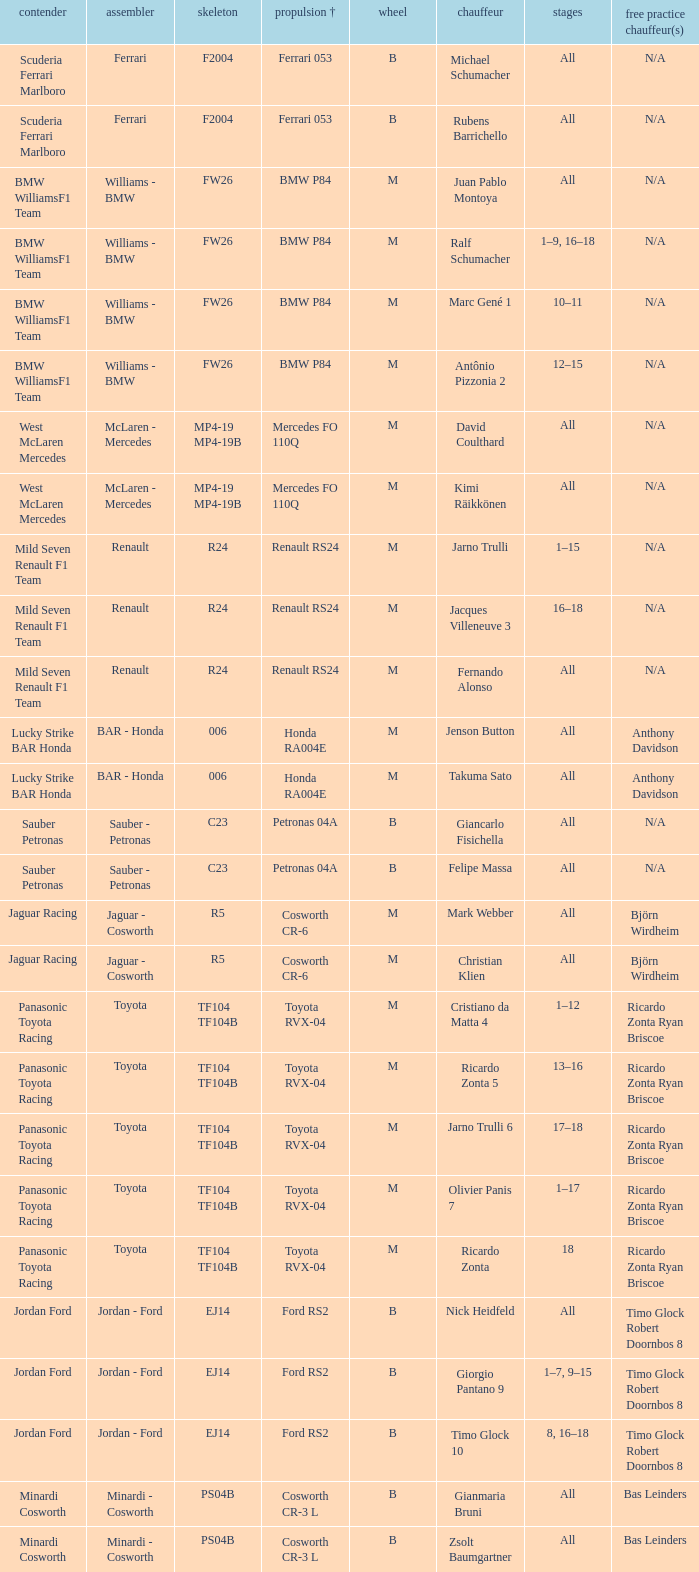What are the rounds for the B tyres and Ferrari 053 engine +? All, All. 